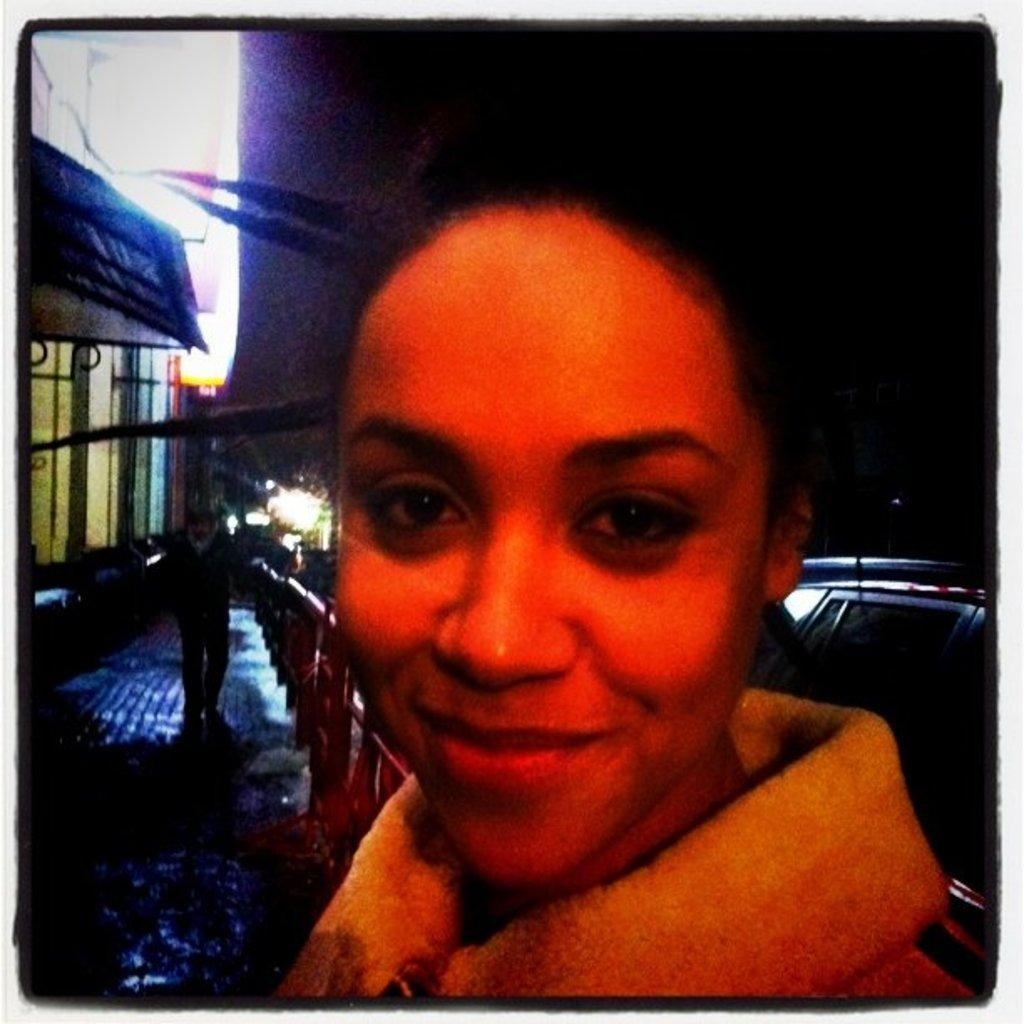What is the main subject of the image? There is a person wearing clothes in the image. Can you describe the other person in the image? There is another person on the left side of the image. What is the person on the left side doing? The person on the left side is walking on a footpath. What topics are being discussed between the two people in the image? There is no indication of a discussion between the two people in the image, as only one person's actions are described. What is the aftermath of the event depicted in the image? There is no event depicted in the image, only the person wearing clothes and the person walking on a footpath. 